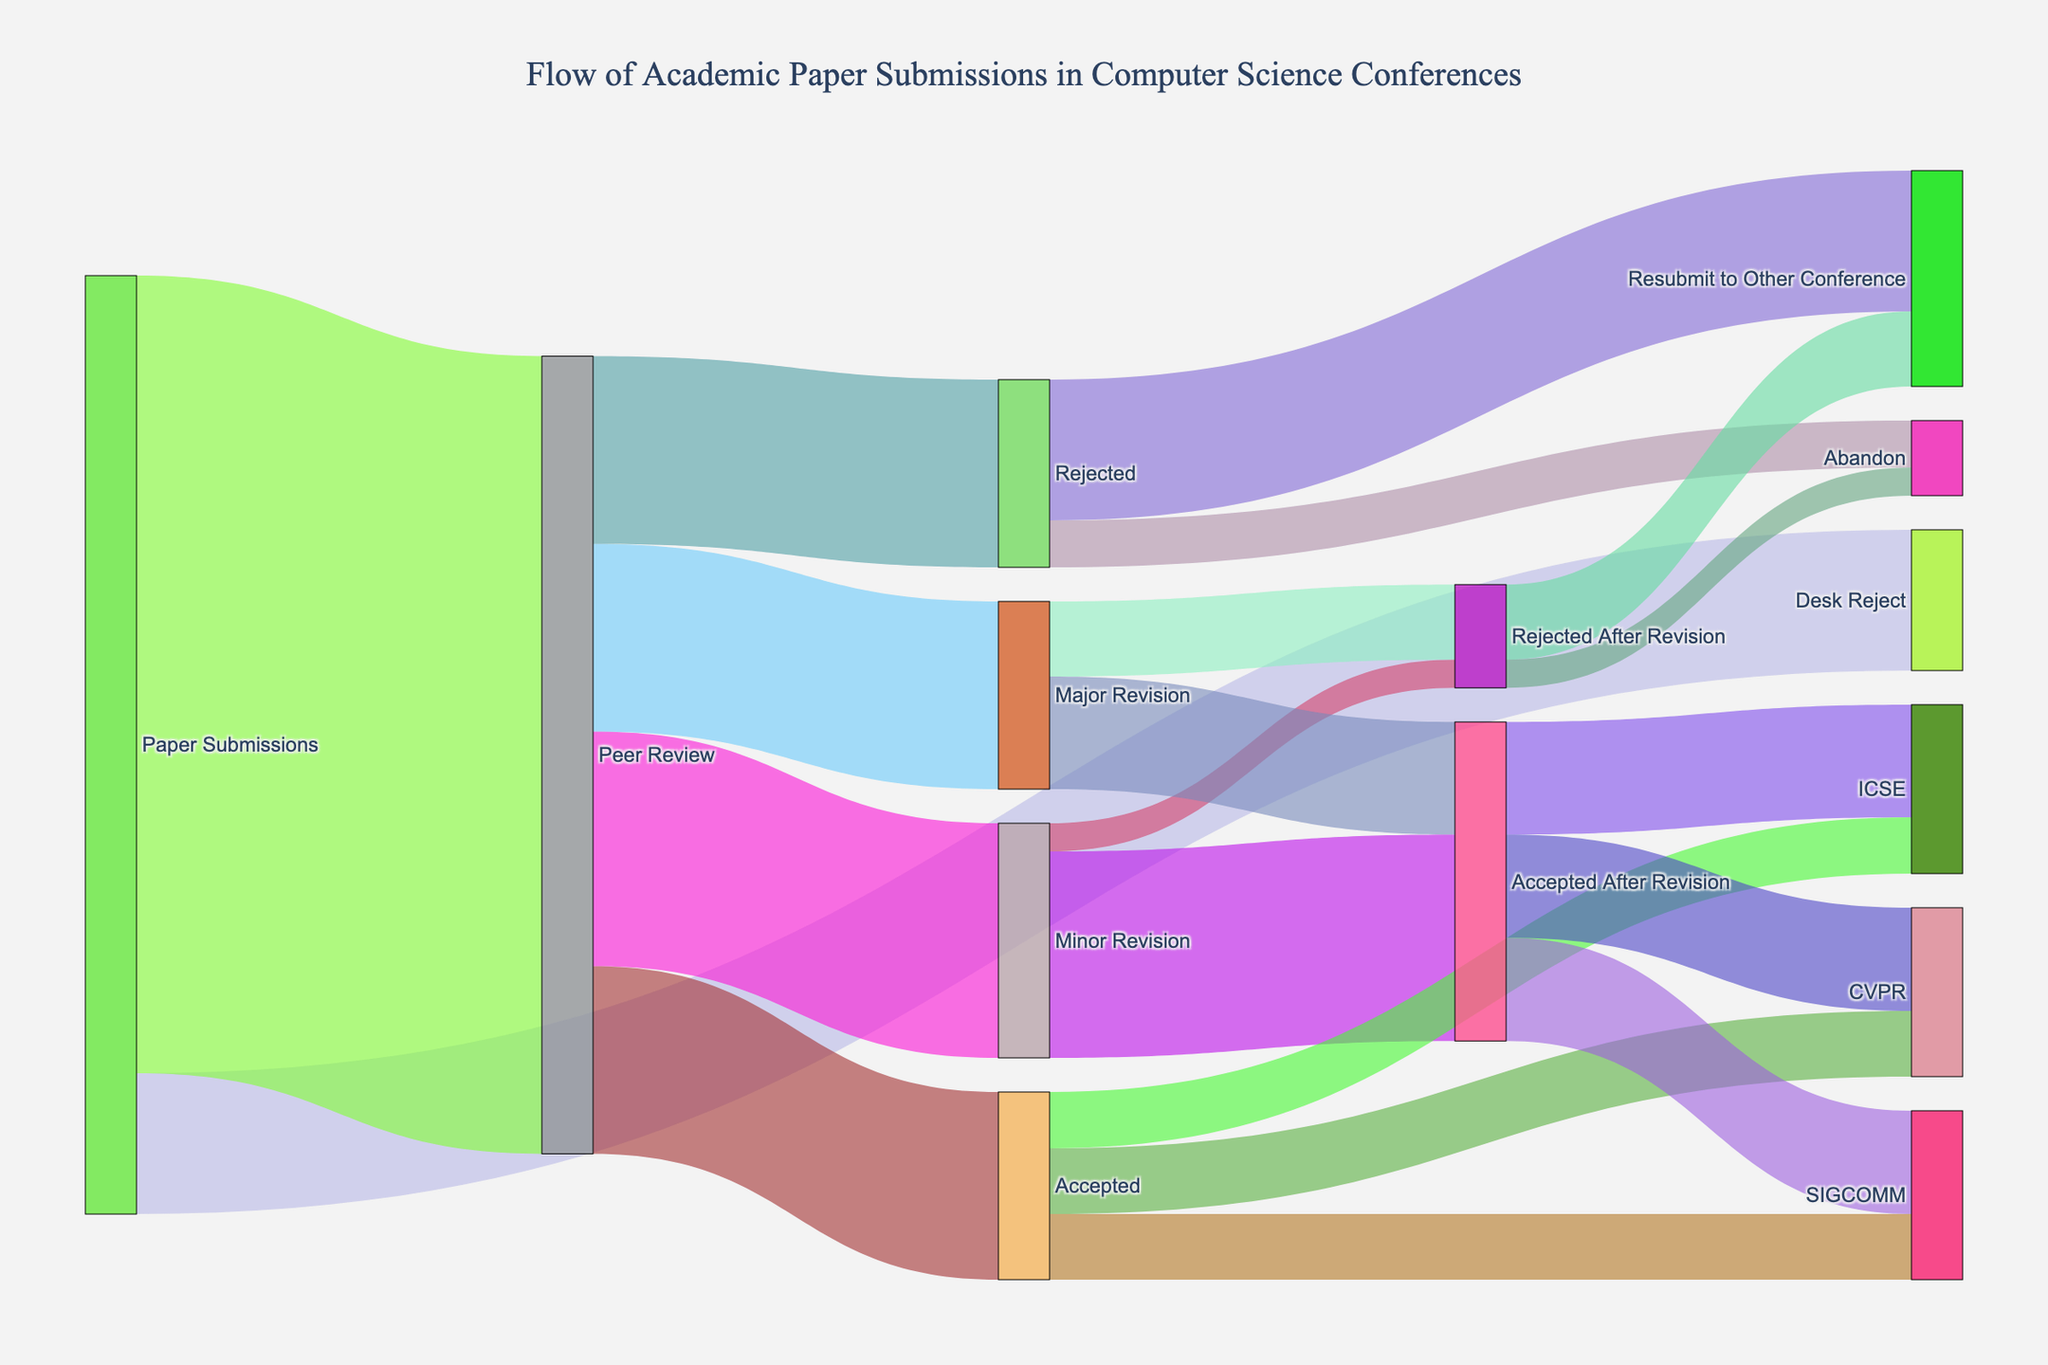Which conference received the highest number of accepted papers after revision? Look at the sections where "Accepted After Revision" splits into different conferences. Compare the numbers corresponding to each conference.
Answer: ICSE What is the total number of papers rejected either initially or after revisions? Add the values corresponding to the "Rejected" and "Rejected After Revision" outcomes. Specifically, look at "Rejected" (200) and the separate rejection totals after "Minor Revision" (30) and "Major Revision" (80). Sum these values: 200 + 30 + 80.
Answer: 310 How many papers were accepted without any need for revision? Look at the section where "Peer Review" splits into different outcomes. The number next to "Accepted" directly gives this value.
Answer: 200 What proportion of submissions went through the peer review process? Refer to the values of "Paper Submissions" branching into "Desk Reject" and "Peer Review". The proportion is the value for "Peer Review" divided by the total submissions: 850 / (150 + 850).
Answer: 85% Compare the number of submissions that ended up in SIGCOMM between papers accepted directly and those accepted after revision. Look at the "Accepted" section leading to SIGCOMM and the "Accepted After Revision" section leading to SIGCOMM. Compare these two values.
Answer: Direct: 70, After Revision: 110 What is the ratio of papers accepted (both initially and after revision) to those abandoned (both initially and after revision)? Sum the total accepted papers (Accepted + Accepted After Revision) and the total abandoned papers (Abandon and Rejected After Revision's Abandon). Accepted: 200 + 220 + 120, Abandoned: 50 + 30. Calculate the ratio: (200 + 220 + 120) / (50 + 30).
Answer: 540 / 80 How many papers were eventually resubmitted to other conferences after being rejected in either stage? Add the values for "Resubmit to Other Conference" outcomes for both rejection stages. Specifically, "Resubmit to Other Conference" from "Rejected" (150) and "Rejected After Revision" (80).
Answer: 230 